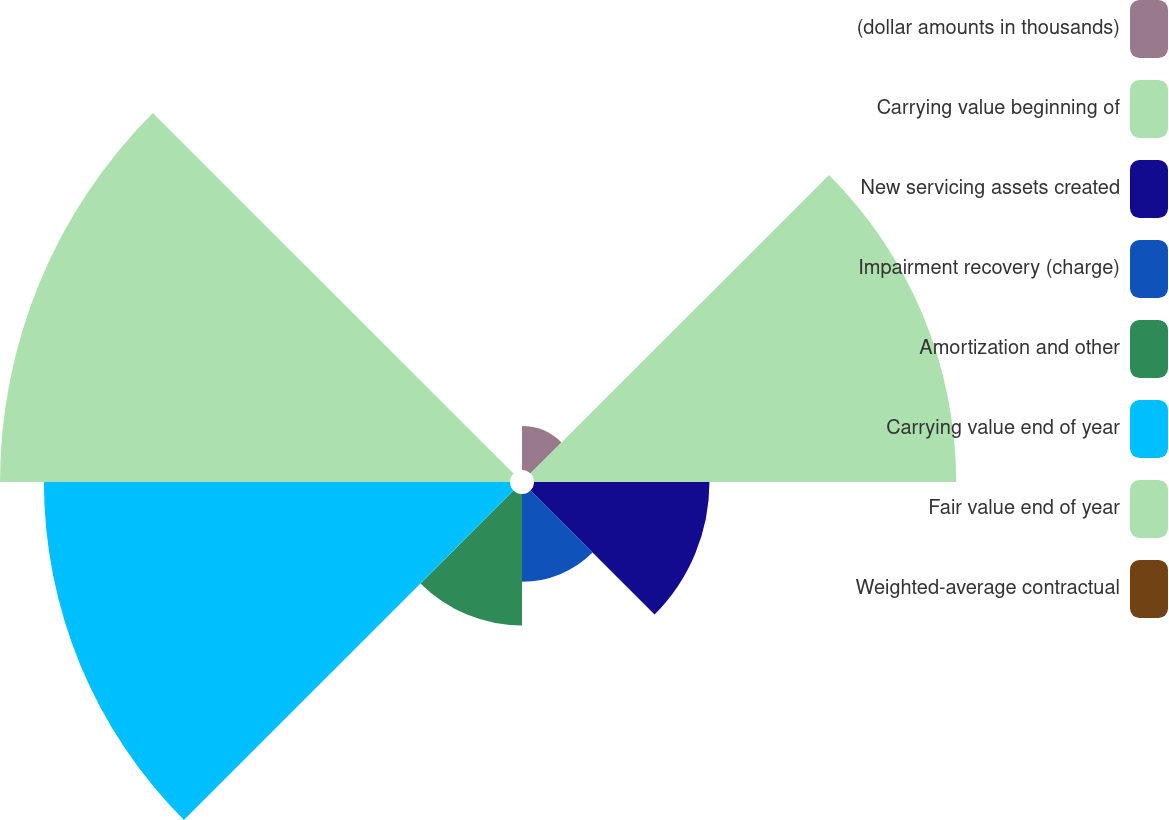Convert chart to OTSL. <chart><loc_0><loc_0><loc_500><loc_500><pie_chart><fcel>(dollar amounts in thousands)<fcel>Carrying value beginning of<fcel>New servicing assets created<fcel>Impairment recovery (charge)<fcel>Amortization and other<fcel>Carrying value end of year<fcel>Fair value end of year<fcel>Weighted-average contractual<nl><fcel>2.39%<fcel>22.98%<fcel>9.55%<fcel>4.78%<fcel>7.16%<fcel>25.37%<fcel>27.76%<fcel>0.0%<nl></chart> 